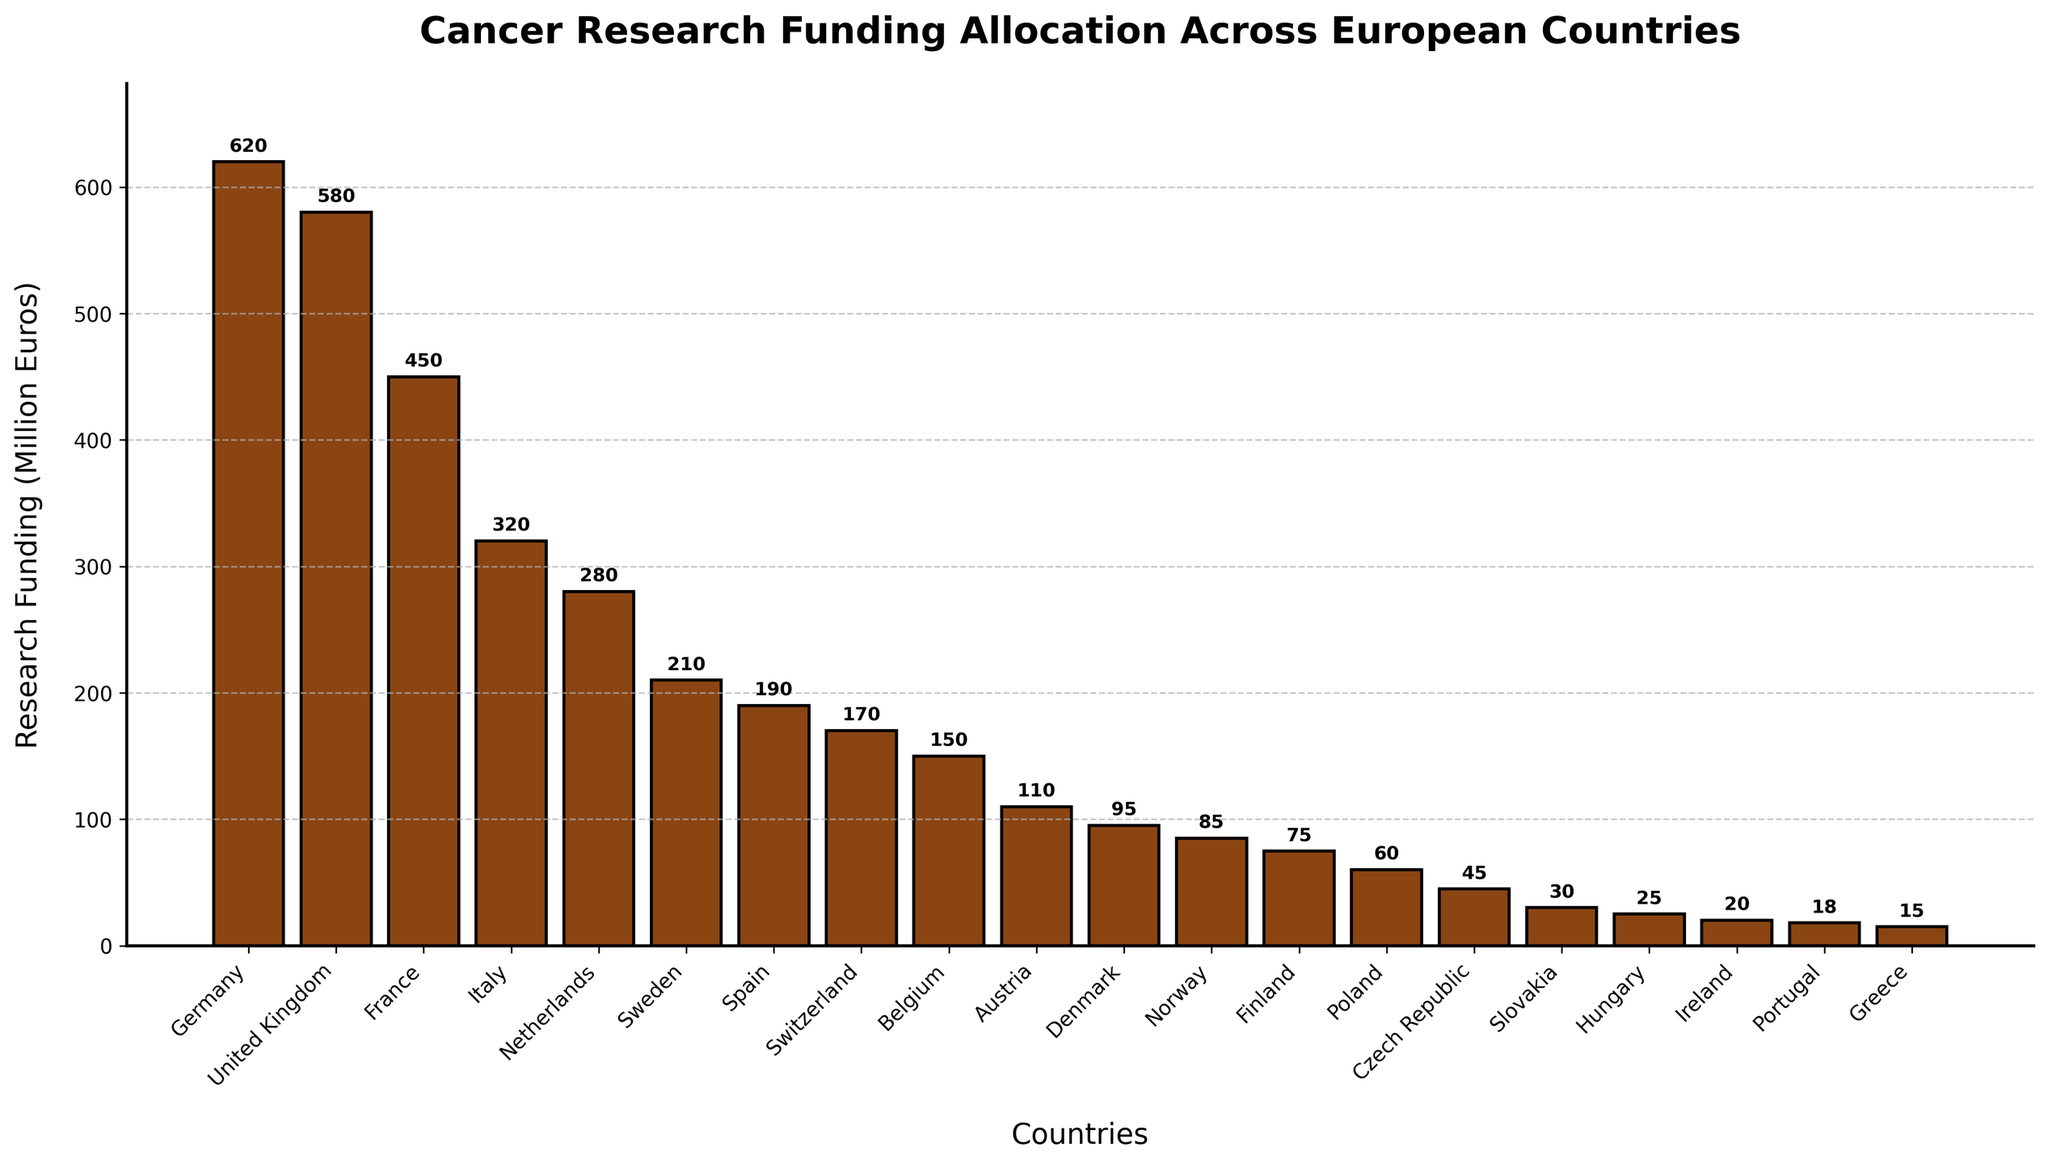Which country has the highest cancer research funding allocation? To determine which country has the highest funding, we look for the tallest bar in the bar chart. Germany has the tallest bar among the countries.
Answer: Germany Which country has the lowest cancer research funding allocation? To find the country with the lowest funding, we look for the shortest bar in the bar chart. Greece has the shortest bar among the countries.
Answer: Greece How much more funding does the United Kingdom have compared to Slovakia? To answer this, we find the funding amounts for both the United Kingdom and Slovakia. The United Kingdom has 580 million euros, and Slovakia has 30 million euros. The difference is 580 - 30 = 550 million euros.
Answer: 550 million euros Which countries have funding allocations between 200 and 300 million euros? We examine the bar heights for each country and identify those that fall within the specified range. The Netherlands (280 million euros) and Sweden (210 million euros) fall within this range.
Answer: Netherlands, Sweden What is the combined cancer research funding allocation for Denmark, Norway, and Finland? To get the combined funding, we sum up the individual amounts for Denmark (95 million euros), Norway (85 million euros), and Finland (75 million euros): 95 + 85 + 75 = 255 million euros.
Answer: 255 million euros How does the research funding for Spain compare to that of Switzerland? We compare the bar heights for Spain and Switzerland. Spain has 190 million euros, while Switzerland has 170 million euros. Since 190 > 170, Spain has more funding than Switzerland.
Answer: Spain has more funding than Switzerland What is the average cancer research funding allocation for the top five funded countries? To find the average, sum the funding amounts for the top five countries: Germany (620), United Kingdom (580), France (450), Italy (320), and Netherlands (280), which equals 620 + 580 + 450 + 320 + 280 = 2250 million euros. Divide this sum by 5: 2250 / 5 = 450 million euros.
Answer: 450 million euros What is the difference in cancer research funding between Belgium and Austria? To find this difference, we subtract the funding for Austria (110 million euros) from Belgium (150 million euros): 150 - 110 = 40 million euros.
Answer: 40 million euros Which country has a funding allocation closest to the median value of all the countries' funding allocations? First, list the countries' allocations and find the median. Sorted values: 15, 18, 20, 25, 30, 45, 60, 75, 85, 95, 110, 150, 170, 190, 210, 280, 320, 450, 580, 620. The median is the average of the two middle values (85 and 95), which is (85+95)/2=90. Norway has the closest funding allocation to 90 million euros with 85 million euros.
Answer: Norway What percentage of total funding is allocated to France? The total funding is the sum of all the given allocations. Adding them gives 620 + 580 + 450 + 320 + 280 + 210 + 190 + 170 + 150 + 110 + 95 + 85 + 75 + 60 + 45 + 30 + 25 + 20 + 18 + 15 = 3548 million euros. The percentage allocation for France is (450 / 3548) * 100%.
Answer: 12.68% 